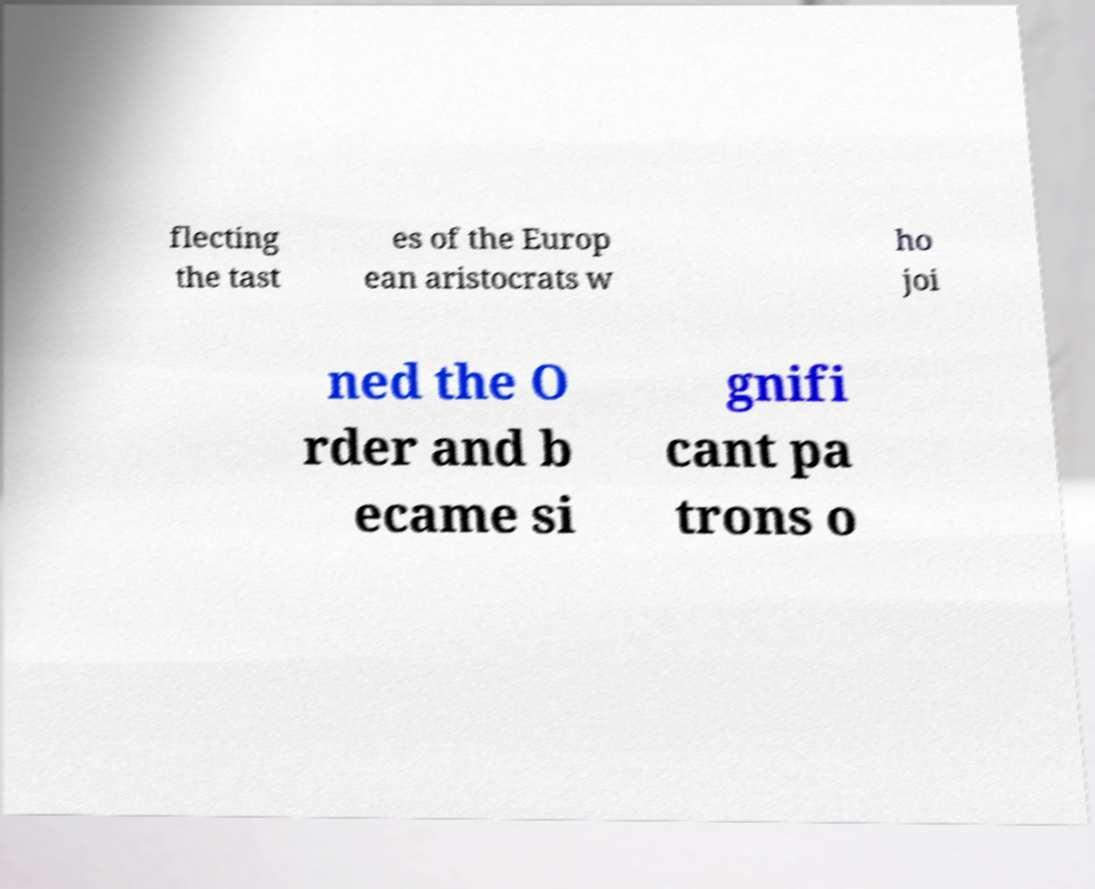Please identify and transcribe the text found in this image. flecting the tast es of the Europ ean aristocrats w ho joi ned the O rder and b ecame si gnifi cant pa trons o 